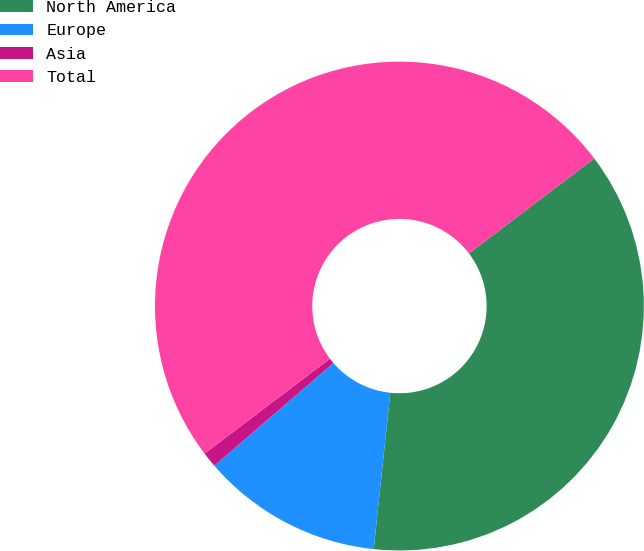Convert chart to OTSL. <chart><loc_0><loc_0><loc_500><loc_500><pie_chart><fcel>North America<fcel>Europe<fcel>Asia<fcel>Total<nl><fcel>37.0%<fcel>12.0%<fcel>1.01%<fcel>50.0%<nl></chart> 